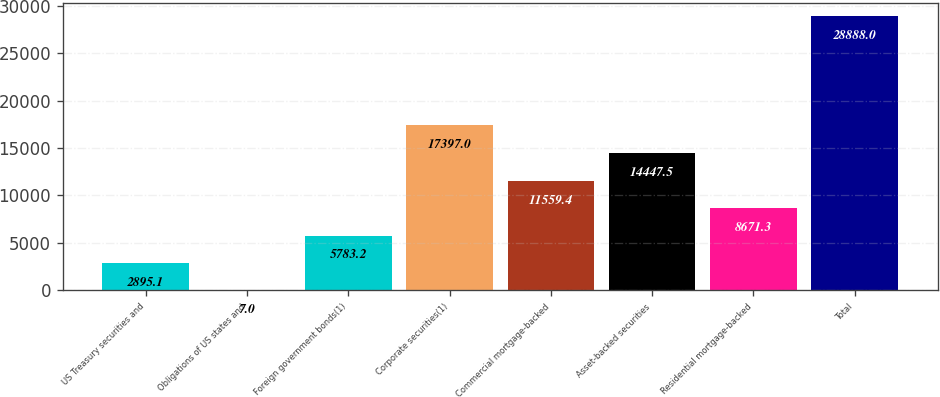Convert chart. <chart><loc_0><loc_0><loc_500><loc_500><bar_chart><fcel>US Treasury securities and<fcel>Obligations of US states and<fcel>Foreign government bonds(1)<fcel>Corporate securities(1)<fcel>Commercial mortgage-backed<fcel>Asset-backed securities<fcel>Residential mortgage-backed<fcel>Total<nl><fcel>2895.1<fcel>7<fcel>5783.2<fcel>17397<fcel>11559.4<fcel>14447.5<fcel>8671.3<fcel>28888<nl></chart> 